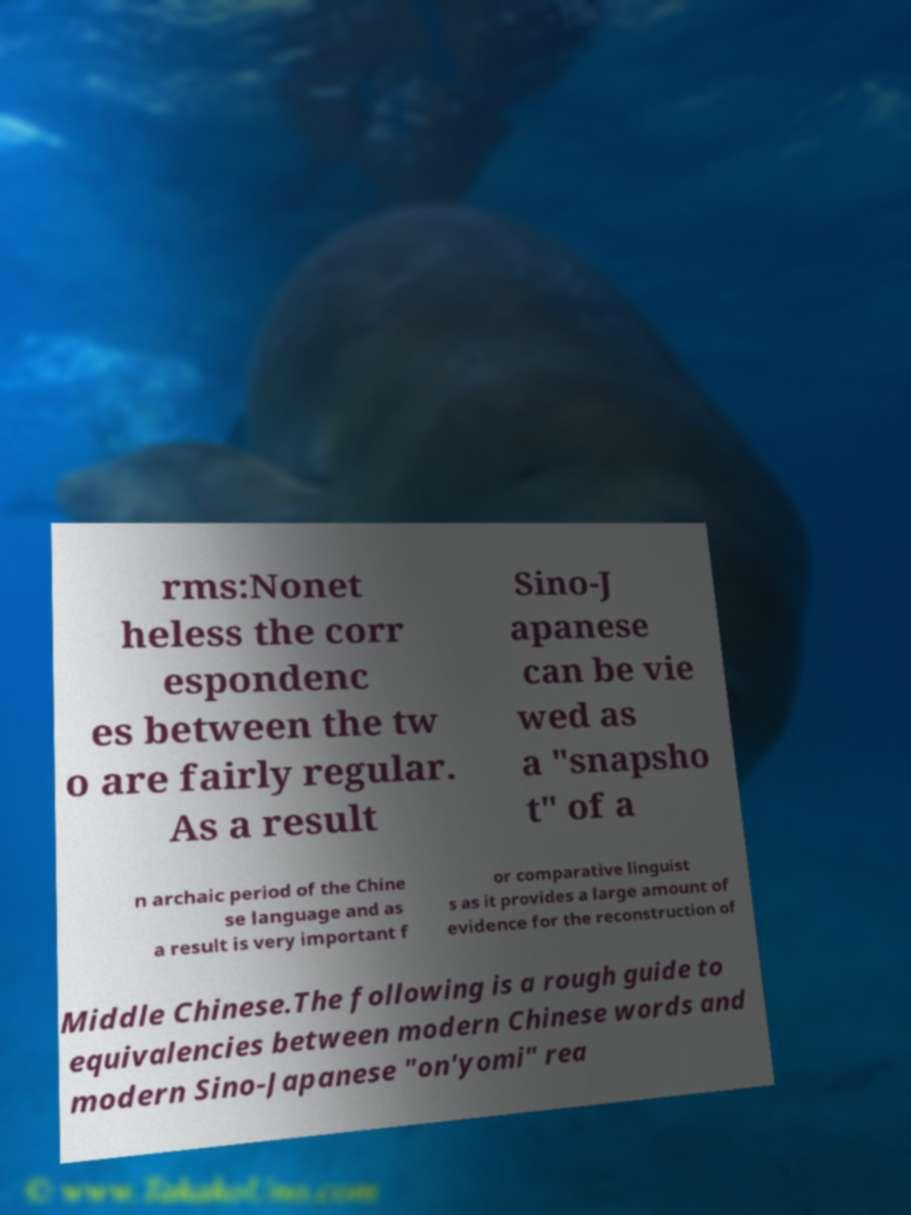There's text embedded in this image that I need extracted. Can you transcribe it verbatim? rms:Nonet heless the corr espondenc es between the tw o are fairly regular. As a result Sino-J apanese can be vie wed as a "snapsho t" of a n archaic period of the Chine se language and as a result is very important f or comparative linguist s as it provides a large amount of evidence for the reconstruction of Middle Chinese.The following is a rough guide to equivalencies between modern Chinese words and modern Sino-Japanese "on'yomi" rea 